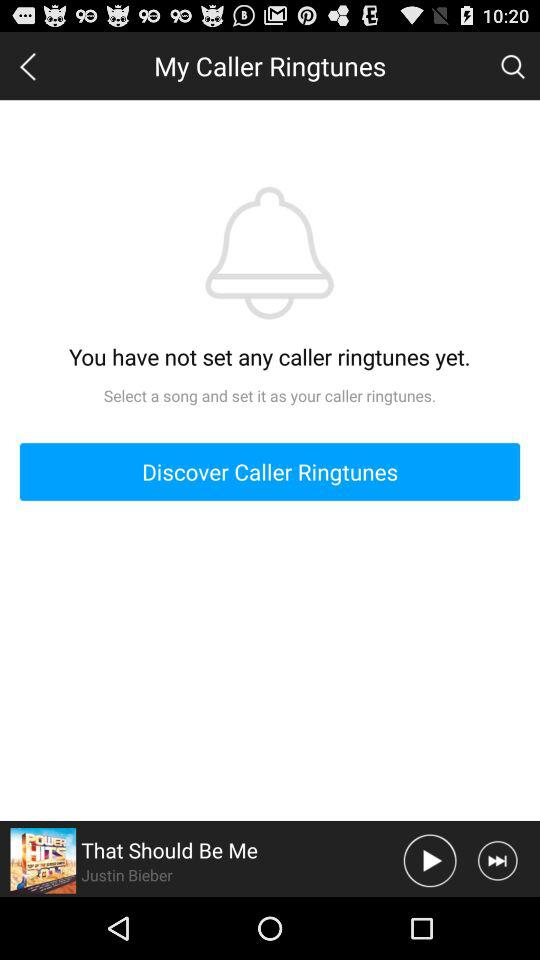Is there any caller ringtune set? The caller ringtune is not set. 